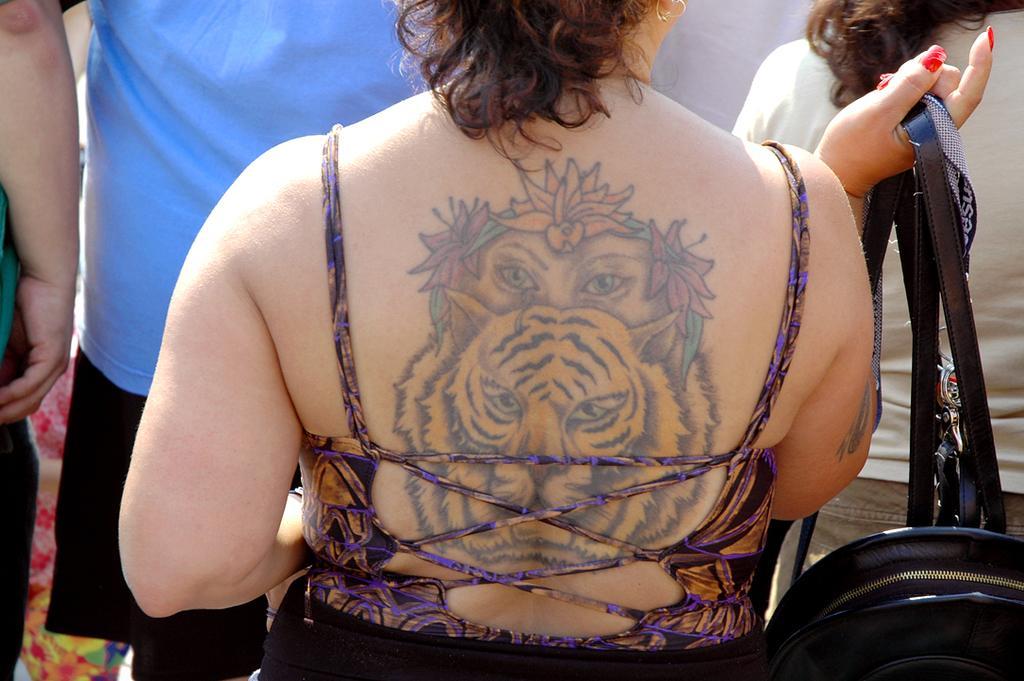Could you give a brief overview of what you see in this image? In this picture I can see a woman holding a bag in her hand and I can see a tattoo on her back and few people standing in the front of her. 